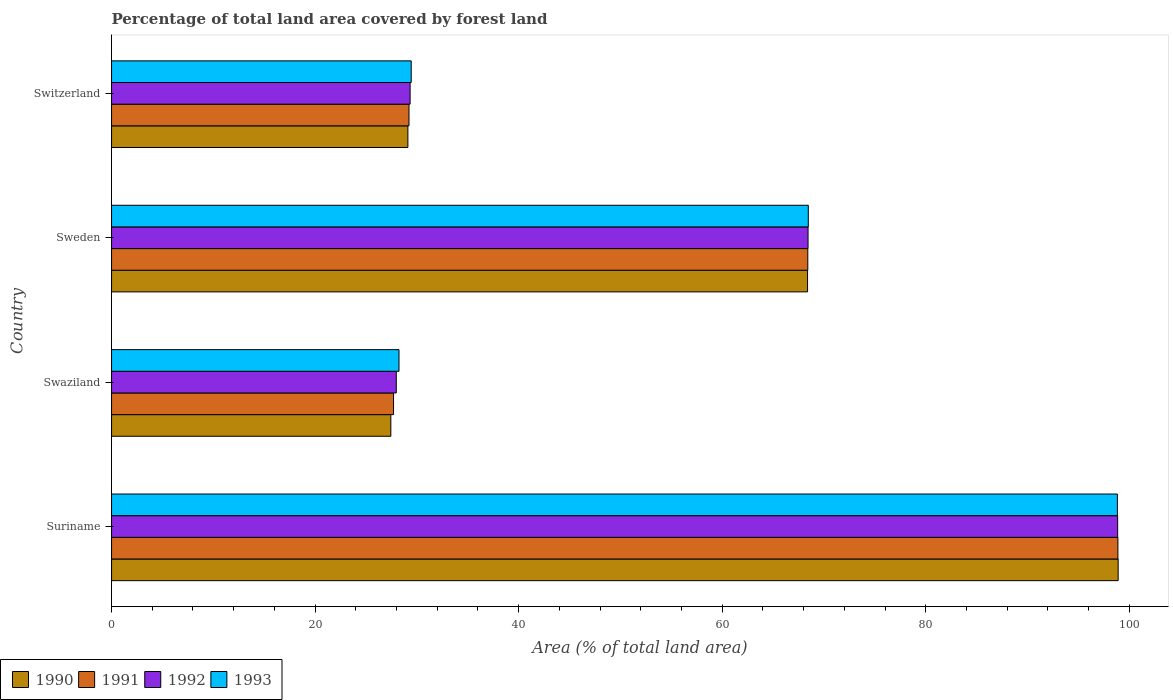How many groups of bars are there?
Your answer should be very brief. 4. Are the number of bars per tick equal to the number of legend labels?
Keep it short and to the point. Yes. Are the number of bars on each tick of the Y-axis equal?
Offer a terse response. Yes. How many bars are there on the 2nd tick from the top?
Keep it short and to the point. 4. What is the label of the 3rd group of bars from the top?
Offer a very short reply. Swaziland. What is the percentage of forest land in 1993 in Sweden?
Your answer should be compact. 68.46. Across all countries, what is the maximum percentage of forest land in 1993?
Provide a succinct answer. 98.84. Across all countries, what is the minimum percentage of forest land in 1993?
Offer a terse response. 28.24. In which country was the percentage of forest land in 1992 maximum?
Your answer should be very brief. Suriname. In which country was the percentage of forest land in 1993 minimum?
Provide a succinct answer. Swaziland. What is the total percentage of forest land in 1993 in the graph?
Your answer should be compact. 224.99. What is the difference between the percentage of forest land in 1991 in Suriname and that in Switzerland?
Ensure brevity in your answer.  69.66. What is the difference between the percentage of forest land in 1991 in Swaziland and the percentage of forest land in 1992 in Sweden?
Make the answer very short. -40.73. What is the average percentage of forest land in 1993 per country?
Offer a very short reply. 56.25. What is the difference between the percentage of forest land in 1992 and percentage of forest land in 1991 in Switzerland?
Offer a terse response. 0.11. What is the ratio of the percentage of forest land in 1991 in Swaziland to that in Switzerland?
Your answer should be compact. 0.95. What is the difference between the highest and the second highest percentage of forest land in 1993?
Give a very brief answer. 30.37. What is the difference between the highest and the lowest percentage of forest land in 1990?
Offer a terse response. 71.47. In how many countries, is the percentage of forest land in 1993 greater than the average percentage of forest land in 1993 taken over all countries?
Make the answer very short. 2. Is it the case that in every country, the sum of the percentage of forest land in 1990 and percentage of forest land in 1992 is greater than the sum of percentage of forest land in 1991 and percentage of forest land in 1993?
Give a very brief answer. No. What does the 4th bar from the bottom in Sweden represents?
Provide a short and direct response. 1993. Are all the bars in the graph horizontal?
Make the answer very short. Yes. What is the difference between two consecutive major ticks on the X-axis?
Ensure brevity in your answer.  20. Does the graph contain any zero values?
Provide a short and direct response. No. Does the graph contain grids?
Make the answer very short. No. Where does the legend appear in the graph?
Your response must be concise. Bottom left. How are the legend labels stacked?
Make the answer very short. Horizontal. What is the title of the graph?
Ensure brevity in your answer.  Percentage of total land area covered by forest land. Does "2006" appear as one of the legend labels in the graph?
Keep it short and to the point. No. What is the label or title of the X-axis?
Make the answer very short. Area (% of total land area). What is the Area (% of total land area) of 1990 in Suriname?
Offer a very short reply. 98.91. What is the Area (% of total land area) in 1991 in Suriname?
Your answer should be compact. 98.89. What is the Area (% of total land area) in 1992 in Suriname?
Keep it short and to the point. 98.86. What is the Area (% of total land area) of 1993 in Suriname?
Keep it short and to the point. 98.84. What is the Area (% of total land area) of 1990 in Swaziland?
Your response must be concise. 27.44. What is the Area (% of total land area) in 1991 in Swaziland?
Offer a very short reply. 27.71. What is the Area (% of total land area) in 1992 in Swaziland?
Keep it short and to the point. 27.98. What is the Area (% of total land area) of 1993 in Swaziland?
Your answer should be compact. 28.24. What is the Area (% of total land area) of 1990 in Sweden?
Offer a very short reply. 68.39. What is the Area (% of total land area) of 1991 in Sweden?
Give a very brief answer. 68.41. What is the Area (% of total land area) of 1992 in Sweden?
Make the answer very short. 68.44. What is the Area (% of total land area) in 1993 in Sweden?
Make the answer very short. 68.46. What is the Area (% of total land area) of 1990 in Switzerland?
Offer a terse response. 29.12. What is the Area (% of total land area) in 1991 in Switzerland?
Provide a short and direct response. 29.23. What is the Area (% of total land area) in 1992 in Switzerland?
Make the answer very short. 29.34. What is the Area (% of total land area) in 1993 in Switzerland?
Make the answer very short. 29.44. Across all countries, what is the maximum Area (% of total land area) of 1990?
Ensure brevity in your answer.  98.91. Across all countries, what is the maximum Area (% of total land area) of 1991?
Your response must be concise. 98.89. Across all countries, what is the maximum Area (% of total land area) in 1992?
Offer a terse response. 98.86. Across all countries, what is the maximum Area (% of total land area) of 1993?
Your answer should be very brief. 98.84. Across all countries, what is the minimum Area (% of total land area) of 1990?
Offer a terse response. 27.44. Across all countries, what is the minimum Area (% of total land area) in 1991?
Your response must be concise. 27.71. Across all countries, what is the minimum Area (% of total land area) in 1992?
Make the answer very short. 27.98. Across all countries, what is the minimum Area (% of total land area) in 1993?
Your answer should be very brief. 28.24. What is the total Area (% of total land area) of 1990 in the graph?
Your answer should be very brief. 223.86. What is the total Area (% of total land area) in 1991 in the graph?
Your answer should be very brief. 224.24. What is the total Area (% of total land area) in 1992 in the graph?
Provide a short and direct response. 224.61. What is the total Area (% of total land area) of 1993 in the graph?
Offer a terse response. 224.99. What is the difference between the Area (% of total land area) of 1990 in Suriname and that in Swaziland?
Give a very brief answer. 71.47. What is the difference between the Area (% of total land area) in 1991 in Suriname and that in Swaziland?
Give a very brief answer. 71.18. What is the difference between the Area (% of total land area) of 1992 in Suriname and that in Swaziland?
Your response must be concise. 70.88. What is the difference between the Area (% of total land area) in 1993 in Suriname and that in Swaziland?
Offer a terse response. 70.59. What is the difference between the Area (% of total land area) of 1990 in Suriname and that in Sweden?
Your response must be concise. 30.52. What is the difference between the Area (% of total land area) in 1991 in Suriname and that in Sweden?
Make the answer very short. 30.47. What is the difference between the Area (% of total land area) of 1992 in Suriname and that in Sweden?
Provide a short and direct response. 30.42. What is the difference between the Area (% of total land area) in 1993 in Suriname and that in Sweden?
Ensure brevity in your answer.  30.37. What is the difference between the Area (% of total land area) in 1990 in Suriname and that in Switzerland?
Make the answer very short. 69.79. What is the difference between the Area (% of total land area) in 1991 in Suriname and that in Switzerland?
Offer a terse response. 69.66. What is the difference between the Area (% of total land area) of 1992 in Suriname and that in Switzerland?
Ensure brevity in your answer.  69.52. What is the difference between the Area (% of total land area) in 1993 in Suriname and that in Switzerland?
Ensure brevity in your answer.  69.39. What is the difference between the Area (% of total land area) in 1990 in Swaziland and that in Sweden?
Make the answer very short. -40.95. What is the difference between the Area (% of total land area) in 1991 in Swaziland and that in Sweden?
Offer a very short reply. -40.7. What is the difference between the Area (% of total land area) in 1992 in Swaziland and that in Sweden?
Your answer should be compact. -40.46. What is the difference between the Area (% of total land area) of 1993 in Swaziland and that in Sweden?
Offer a very short reply. -40.22. What is the difference between the Area (% of total land area) of 1990 in Swaziland and that in Switzerland?
Provide a succinct answer. -1.68. What is the difference between the Area (% of total land area) in 1991 in Swaziland and that in Switzerland?
Ensure brevity in your answer.  -1.52. What is the difference between the Area (% of total land area) of 1992 in Swaziland and that in Switzerland?
Provide a succinct answer. -1.36. What is the difference between the Area (% of total land area) in 1990 in Sweden and that in Switzerland?
Provide a succinct answer. 39.27. What is the difference between the Area (% of total land area) of 1991 in Sweden and that in Switzerland?
Your answer should be compact. 39.19. What is the difference between the Area (% of total land area) of 1992 in Sweden and that in Switzerland?
Offer a terse response. 39.1. What is the difference between the Area (% of total land area) of 1993 in Sweden and that in Switzerland?
Provide a succinct answer. 39.02. What is the difference between the Area (% of total land area) of 1990 in Suriname and the Area (% of total land area) of 1991 in Swaziland?
Offer a terse response. 71.2. What is the difference between the Area (% of total land area) in 1990 in Suriname and the Area (% of total land area) in 1992 in Swaziland?
Offer a terse response. 70.93. What is the difference between the Area (% of total land area) in 1990 in Suriname and the Area (% of total land area) in 1993 in Swaziland?
Your answer should be compact. 70.67. What is the difference between the Area (% of total land area) of 1991 in Suriname and the Area (% of total land area) of 1992 in Swaziland?
Give a very brief answer. 70.91. What is the difference between the Area (% of total land area) of 1991 in Suriname and the Area (% of total land area) of 1993 in Swaziland?
Keep it short and to the point. 70.64. What is the difference between the Area (% of total land area) of 1992 in Suriname and the Area (% of total land area) of 1993 in Swaziland?
Provide a succinct answer. 70.62. What is the difference between the Area (% of total land area) in 1990 in Suriname and the Area (% of total land area) in 1991 in Sweden?
Offer a terse response. 30.5. What is the difference between the Area (% of total land area) in 1990 in Suriname and the Area (% of total land area) in 1992 in Sweden?
Offer a terse response. 30.47. What is the difference between the Area (% of total land area) in 1990 in Suriname and the Area (% of total land area) in 1993 in Sweden?
Offer a terse response. 30.45. What is the difference between the Area (% of total land area) in 1991 in Suriname and the Area (% of total land area) in 1992 in Sweden?
Make the answer very short. 30.45. What is the difference between the Area (% of total land area) in 1991 in Suriname and the Area (% of total land area) in 1993 in Sweden?
Give a very brief answer. 30.42. What is the difference between the Area (% of total land area) of 1992 in Suriname and the Area (% of total land area) of 1993 in Sweden?
Provide a succinct answer. 30.4. What is the difference between the Area (% of total land area) of 1990 in Suriname and the Area (% of total land area) of 1991 in Switzerland?
Make the answer very short. 69.68. What is the difference between the Area (% of total land area) of 1990 in Suriname and the Area (% of total land area) of 1992 in Switzerland?
Make the answer very short. 69.57. What is the difference between the Area (% of total land area) in 1990 in Suriname and the Area (% of total land area) in 1993 in Switzerland?
Offer a terse response. 69.47. What is the difference between the Area (% of total land area) of 1991 in Suriname and the Area (% of total land area) of 1992 in Switzerland?
Your answer should be very brief. 69.55. What is the difference between the Area (% of total land area) of 1991 in Suriname and the Area (% of total land area) of 1993 in Switzerland?
Offer a very short reply. 69.44. What is the difference between the Area (% of total land area) of 1992 in Suriname and the Area (% of total land area) of 1993 in Switzerland?
Your response must be concise. 69.42. What is the difference between the Area (% of total land area) of 1990 in Swaziland and the Area (% of total land area) of 1991 in Sweden?
Provide a succinct answer. -40.97. What is the difference between the Area (% of total land area) of 1990 in Swaziland and the Area (% of total land area) of 1992 in Sweden?
Provide a short and direct response. -41. What is the difference between the Area (% of total land area) of 1990 in Swaziland and the Area (% of total land area) of 1993 in Sweden?
Ensure brevity in your answer.  -41.02. What is the difference between the Area (% of total land area) in 1991 in Swaziland and the Area (% of total land area) in 1992 in Sweden?
Give a very brief answer. -40.73. What is the difference between the Area (% of total land area) in 1991 in Swaziland and the Area (% of total land area) in 1993 in Sweden?
Your answer should be compact. -40.75. What is the difference between the Area (% of total land area) in 1992 in Swaziland and the Area (% of total land area) in 1993 in Sweden?
Your response must be concise. -40.49. What is the difference between the Area (% of total land area) in 1990 in Swaziland and the Area (% of total land area) in 1991 in Switzerland?
Provide a succinct answer. -1.78. What is the difference between the Area (% of total land area) of 1990 in Swaziland and the Area (% of total land area) of 1992 in Switzerland?
Make the answer very short. -1.89. What is the difference between the Area (% of total land area) of 1990 in Swaziland and the Area (% of total land area) of 1993 in Switzerland?
Your response must be concise. -2. What is the difference between the Area (% of total land area) of 1991 in Swaziland and the Area (% of total land area) of 1992 in Switzerland?
Your answer should be very brief. -1.63. What is the difference between the Area (% of total land area) in 1991 in Swaziland and the Area (% of total land area) in 1993 in Switzerland?
Make the answer very short. -1.73. What is the difference between the Area (% of total land area) in 1992 in Swaziland and the Area (% of total land area) in 1993 in Switzerland?
Make the answer very short. -1.47. What is the difference between the Area (% of total land area) of 1990 in Sweden and the Area (% of total land area) of 1991 in Switzerland?
Offer a terse response. 39.16. What is the difference between the Area (% of total land area) in 1990 in Sweden and the Area (% of total land area) in 1992 in Switzerland?
Give a very brief answer. 39.05. What is the difference between the Area (% of total land area) of 1990 in Sweden and the Area (% of total land area) of 1993 in Switzerland?
Make the answer very short. 38.95. What is the difference between the Area (% of total land area) in 1991 in Sweden and the Area (% of total land area) in 1992 in Switzerland?
Your answer should be very brief. 39.08. What is the difference between the Area (% of total land area) of 1991 in Sweden and the Area (% of total land area) of 1993 in Switzerland?
Offer a terse response. 38.97. What is the difference between the Area (% of total land area) of 1992 in Sweden and the Area (% of total land area) of 1993 in Switzerland?
Offer a terse response. 38.99. What is the average Area (% of total land area) in 1990 per country?
Make the answer very short. 55.96. What is the average Area (% of total land area) of 1991 per country?
Keep it short and to the point. 56.06. What is the average Area (% of total land area) in 1992 per country?
Provide a succinct answer. 56.15. What is the average Area (% of total land area) in 1993 per country?
Offer a very short reply. 56.25. What is the difference between the Area (% of total land area) of 1990 and Area (% of total land area) of 1991 in Suriname?
Your response must be concise. 0.03. What is the difference between the Area (% of total land area) in 1990 and Area (% of total land area) in 1993 in Suriname?
Provide a short and direct response. 0.07. What is the difference between the Area (% of total land area) in 1991 and Area (% of total land area) in 1992 in Suriname?
Ensure brevity in your answer.  0.03. What is the difference between the Area (% of total land area) of 1992 and Area (% of total land area) of 1993 in Suriname?
Provide a succinct answer. 0.03. What is the difference between the Area (% of total land area) of 1990 and Area (% of total land area) of 1991 in Swaziland?
Offer a terse response. -0.27. What is the difference between the Area (% of total land area) of 1990 and Area (% of total land area) of 1992 in Swaziland?
Offer a terse response. -0.53. What is the difference between the Area (% of total land area) in 1990 and Area (% of total land area) in 1993 in Swaziland?
Provide a short and direct response. -0.8. What is the difference between the Area (% of total land area) of 1991 and Area (% of total land area) of 1992 in Swaziland?
Ensure brevity in your answer.  -0.27. What is the difference between the Area (% of total land area) in 1991 and Area (% of total land area) in 1993 in Swaziland?
Make the answer very short. -0.53. What is the difference between the Area (% of total land area) in 1992 and Area (% of total land area) in 1993 in Swaziland?
Offer a terse response. -0.27. What is the difference between the Area (% of total land area) of 1990 and Area (% of total land area) of 1991 in Sweden?
Make the answer very short. -0.02. What is the difference between the Area (% of total land area) of 1990 and Area (% of total land area) of 1992 in Sweden?
Give a very brief answer. -0.05. What is the difference between the Area (% of total land area) in 1990 and Area (% of total land area) in 1993 in Sweden?
Your answer should be compact. -0.07. What is the difference between the Area (% of total land area) of 1991 and Area (% of total land area) of 1992 in Sweden?
Provide a succinct answer. -0.02. What is the difference between the Area (% of total land area) in 1991 and Area (% of total land area) in 1993 in Sweden?
Provide a succinct answer. -0.05. What is the difference between the Area (% of total land area) of 1992 and Area (% of total land area) of 1993 in Sweden?
Your answer should be compact. -0.02. What is the difference between the Area (% of total land area) of 1990 and Area (% of total land area) of 1991 in Switzerland?
Offer a terse response. -0.11. What is the difference between the Area (% of total land area) of 1990 and Area (% of total land area) of 1992 in Switzerland?
Your answer should be compact. -0.22. What is the difference between the Area (% of total land area) in 1990 and Area (% of total land area) in 1993 in Switzerland?
Give a very brief answer. -0.33. What is the difference between the Area (% of total land area) in 1991 and Area (% of total land area) in 1992 in Switzerland?
Provide a short and direct response. -0.11. What is the difference between the Area (% of total land area) of 1991 and Area (% of total land area) of 1993 in Switzerland?
Offer a terse response. -0.22. What is the difference between the Area (% of total land area) in 1992 and Area (% of total land area) in 1993 in Switzerland?
Your answer should be very brief. -0.11. What is the ratio of the Area (% of total land area) of 1990 in Suriname to that in Swaziland?
Your answer should be very brief. 3.6. What is the ratio of the Area (% of total land area) in 1991 in Suriname to that in Swaziland?
Your answer should be very brief. 3.57. What is the ratio of the Area (% of total land area) in 1992 in Suriname to that in Swaziland?
Offer a very short reply. 3.53. What is the ratio of the Area (% of total land area) of 1993 in Suriname to that in Swaziland?
Ensure brevity in your answer.  3.5. What is the ratio of the Area (% of total land area) of 1990 in Suriname to that in Sweden?
Your answer should be compact. 1.45. What is the ratio of the Area (% of total land area) of 1991 in Suriname to that in Sweden?
Keep it short and to the point. 1.45. What is the ratio of the Area (% of total land area) of 1992 in Suriname to that in Sweden?
Offer a very short reply. 1.44. What is the ratio of the Area (% of total land area) of 1993 in Suriname to that in Sweden?
Provide a succinct answer. 1.44. What is the ratio of the Area (% of total land area) in 1990 in Suriname to that in Switzerland?
Your answer should be compact. 3.4. What is the ratio of the Area (% of total land area) of 1991 in Suriname to that in Switzerland?
Provide a short and direct response. 3.38. What is the ratio of the Area (% of total land area) in 1992 in Suriname to that in Switzerland?
Provide a succinct answer. 3.37. What is the ratio of the Area (% of total land area) in 1993 in Suriname to that in Switzerland?
Your answer should be compact. 3.36. What is the ratio of the Area (% of total land area) of 1990 in Swaziland to that in Sweden?
Offer a very short reply. 0.4. What is the ratio of the Area (% of total land area) of 1991 in Swaziland to that in Sweden?
Offer a very short reply. 0.41. What is the ratio of the Area (% of total land area) in 1992 in Swaziland to that in Sweden?
Your answer should be very brief. 0.41. What is the ratio of the Area (% of total land area) in 1993 in Swaziland to that in Sweden?
Keep it short and to the point. 0.41. What is the ratio of the Area (% of total land area) in 1990 in Swaziland to that in Switzerland?
Provide a short and direct response. 0.94. What is the ratio of the Area (% of total land area) in 1991 in Swaziland to that in Switzerland?
Provide a short and direct response. 0.95. What is the ratio of the Area (% of total land area) of 1992 in Swaziland to that in Switzerland?
Offer a terse response. 0.95. What is the ratio of the Area (% of total land area) in 1993 in Swaziland to that in Switzerland?
Your answer should be compact. 0.96. What is the ratio of the Area (% of total land area) of 1990 in Sweden to that in Switzerland?
Ensure brevity in your answer.  2.35. What is the ratio of the Area (% of total land area) in 1991 in Sweden to that in Switzerland?
Give a very brief answer. 2.34. What is the ratio of the Area (% of total land area) of 1992 in Sweden to that in Switzerland?
Your answer should be compact. 2.33. What is the ratio of the Area (% of total land area) in 1993 in Sweden to that in Switzerland?
Provide a succinct answer. 2.33. What is the difference between the highest and the second highest Area (% of total land area) of 1990?
Your answer should be compact. 30.52. What is the difference between the highest and the second highest Area (% of total land area) of 1991?
Give a very brief answer. 30.47. What is the difference between the highest and the second highest Area (% of total land area) in 1992?
Provide a short and direct response. 30.42. What is the difference between the highest and the second highest Area (% of total land area) in 1993?
Provide a succinct answer. 30.37. What is the difference between the highest and the lowest Area (% of total land area) in 1990?
Offer a terse response. 71.47. What is the difference between the highest and the lowest Area (% of total land area) in 1991?
Give a very brief answer. 71.18. What is the difference between the highest and the lowest Area (% of total land area) of 1992?
Keep it short and to the point. 70.88. What is the difference between the highest and the lowest Area (% of total land area) of 1993?
Make the answer very short. 70.59. 